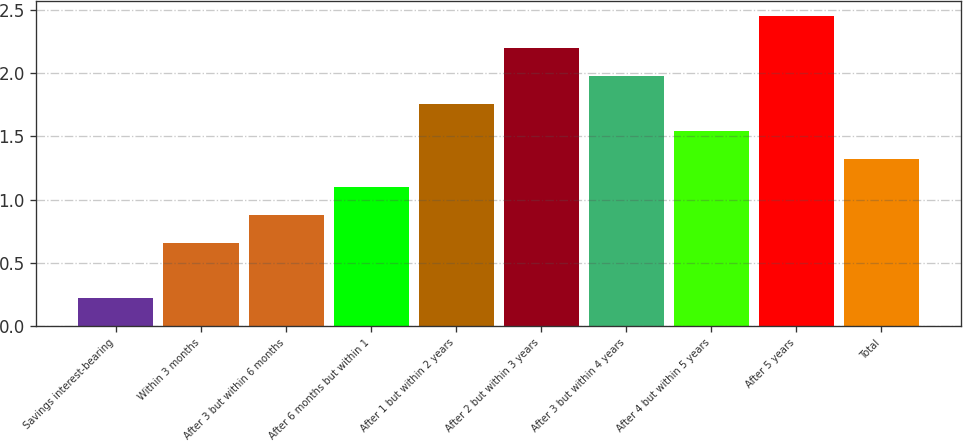Convert chart to OTSL. <chart><loc_0><loc_0><loc_500><loc_500><bar_chart><fcel>Savings interest-bearing<fcel>Within 3 months<fcel>After 3 but within 6 months<fcel>After 6 months but within 1<fcel>After 1 but within 2 years<fcel>After 2 but within 3 years<fcel>After 3 but within 4 years<fcel>After 4 but within 5 years<fcel>After 5 years<fcel>Total<nl><fcel>0.22<fcel>0.66<fcel>0.88<fcel>1.1<fcel>1.76<fcel>2.2<fcel>1.98<fcel>1.54<fcel>2.45<fcel>1.32<nl></chart> 